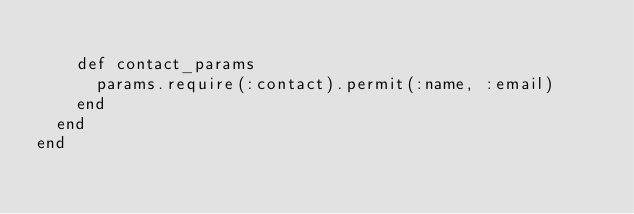<code> <loc_0><loc_0><loc_500><loc_500><_Ruby_>
    def contact_params
      params.require(:contact).permit(:name, :email)
    end
  end
end
</code> 